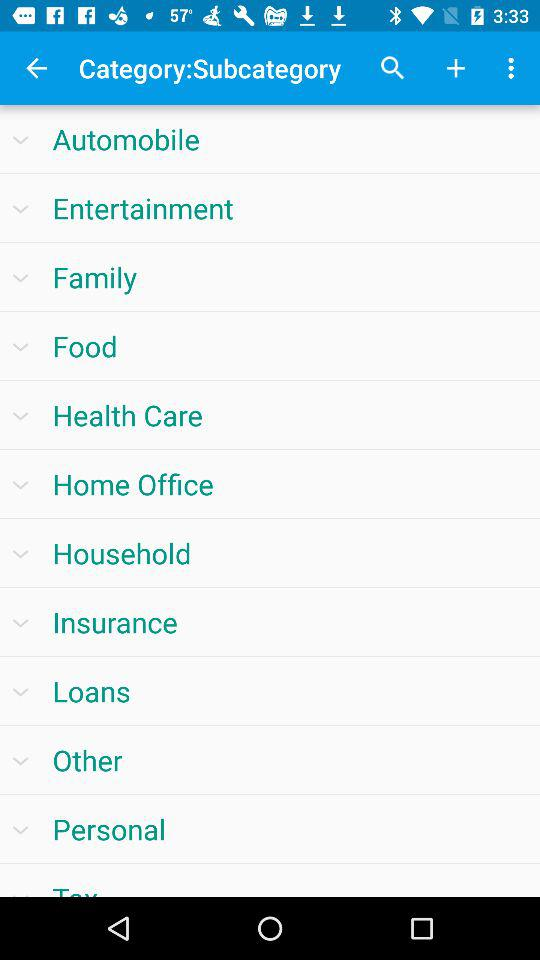What are the different categories available? The different categories available are "Automobile", "Entertainment", "Family", "Food", "Health Care", "Home Office", "Household", "Insurance", "Loans", "Other" and "Personal". 